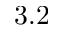<formula> <loc_0><loc_0><loc_500><loc_500>3 . 2</formula> 